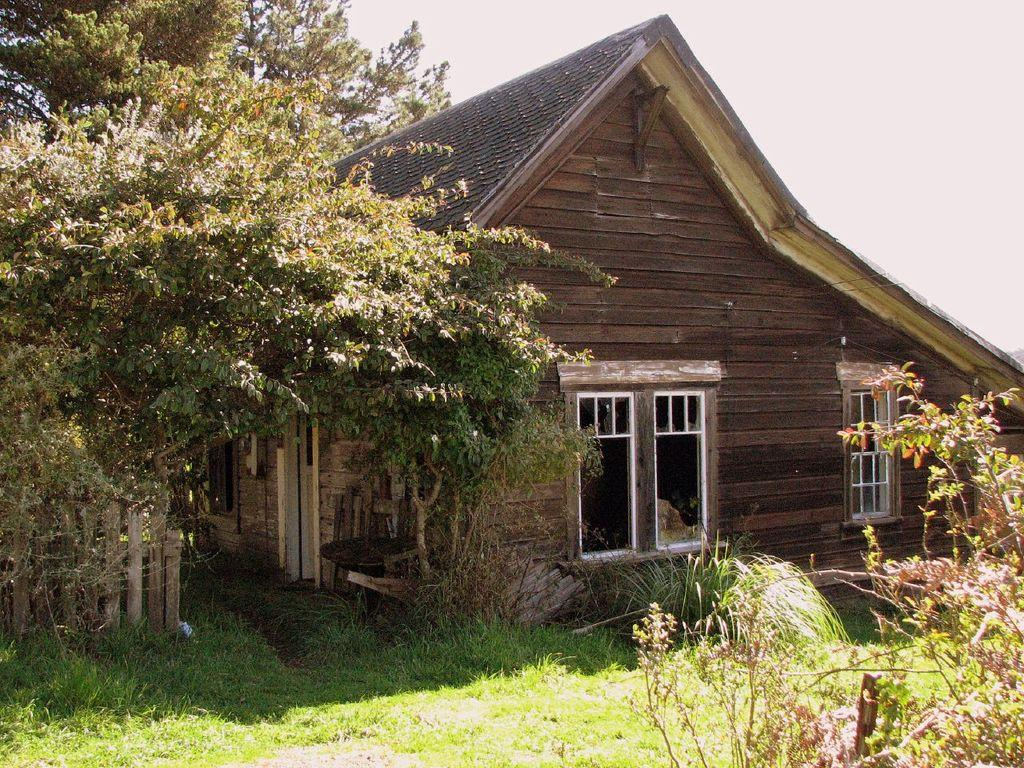What type of ground is visible in the image? There is grass ground in the image. What other natural elements can be seen in the image? There are plants and trees in the image. What type of structure is present in the image? There is a house in the image. What feature of the house is mentioned in the facts? The house has windows. What type of fencing is visible in the image? There is wooden fencing on the bottom left side of the image. What part of the natural environment is visible in the background of the image? The sky is visible in the background of the image. What type of attraction can be seen in the image? There is no attraction present in the image; it features a house, grass ground, plants, trees, wooden fencing, and the sky. What type of art is displayed on the house in the image? There is no art displayed on the house in the image; it only has windows mentioned in the facts. 